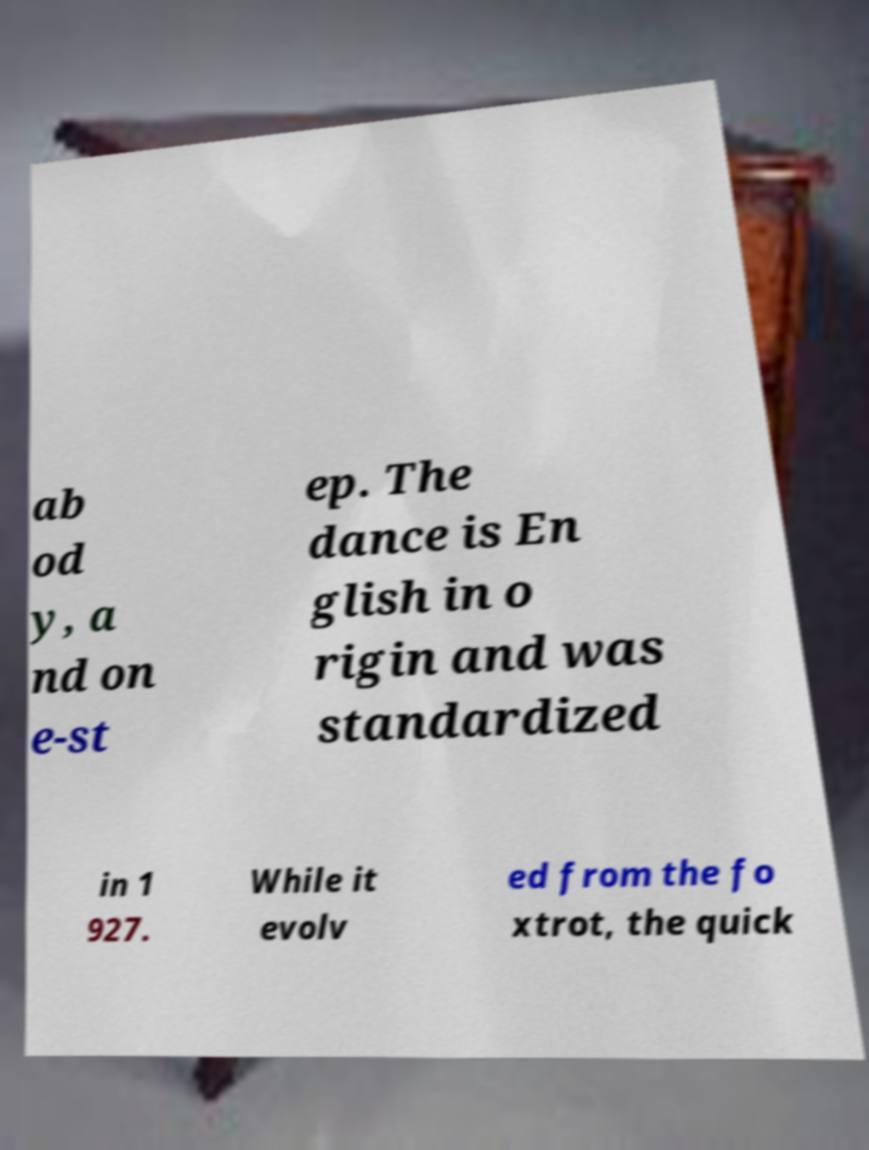Could you assist in decoding the text presented in this image and type it out clearly? ab od y, a nd on e-st ep. The dance is En glish in o rigin and was standardized in 1 927. While it evolv ed from the fo xtrot, the quick 